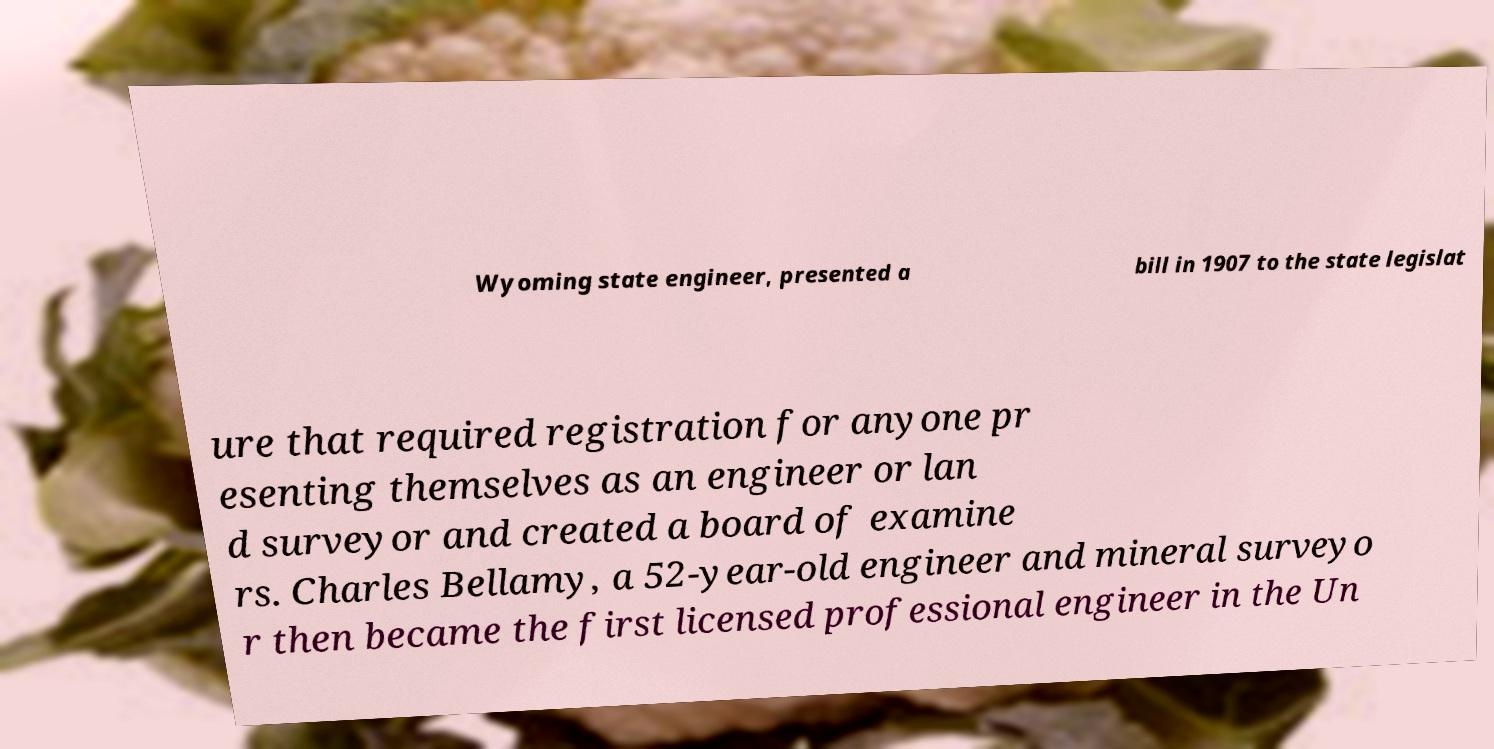There's text embedded in this image that I need extracted. Can you transcribe it verbatim? Wyoming state engineer, presented a bill in 1907 to the state legislat ure that required registration for anyone pr esenting themselves as an engineer or lan d surveyor and created a board of examine rs. Charles Bellamy, a 52-year-old engineer and mineral surveyo r then became the first licensed professional engineer in the Un 